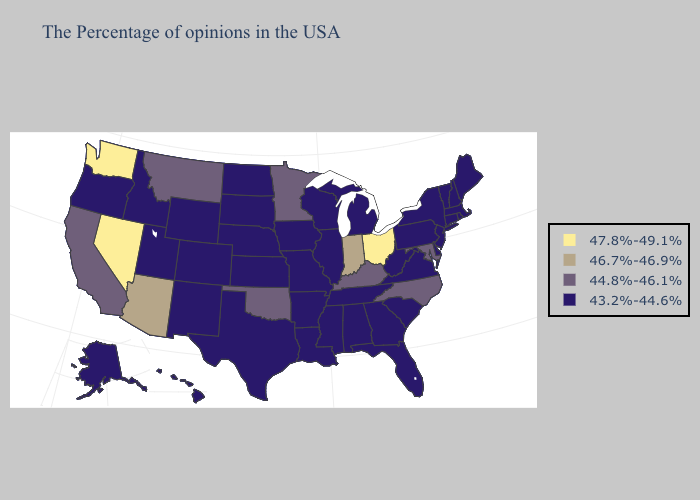Name the states that have a value in the range 44.8%-46.1%?
Answer briefly. Maryland, North Carolina, Kentucky, Minnesota, Oklahoma, Montana, California. What is the lowest value in the Northeast?
Concise answer only. 43.2%-44.6%. Does Ohio have the lowest value in the USA?
Quick response, please. No. What is the value of Alabama?
Short answer required. 43.2%-44.6%. What is the highest value in the West ?
Write a very short answer. 47.8%-49.1%. What is the lowest value in the MidWest?
Concise answer only. 43.2%-44.6%. Which states hav the highest value in the MidWest?
Be succinct. Ohio. Does Ohio have the highest value in the MidWest?
Be succinct. Yes. Name the states that have a value in the range 43.2%-44.6%?
Concise answer only. Maine, Massachusetts, Rhode Island, New Hampshire, Vermont, Connecticut, New York, New Jersey, Delaware, Pennsylvania, Virginia, South Carolina, West Virginia, Florida, Georgia, Michigan, Alabama, Tennessee, Wisconsin, Illinois, Mississippi, Louisiana, Missouri, Arkansas, Iowa, Kansas, Nebraska, Texas, South Dakota, North Dakota, Wyoming, Colorado, New Mexico, Utah, Idaho, Oregon, Alaska, Hawaii. What is the highest value in the USA?
Be succinct. 47.8%-49.1%. What is the value of North Dakota?
Concise answer only. 43.2%-44.6%. What is the value of Mississippi?
Answer briefly. 43.2%-44.6%. Does Missouri have the lowest value in the USA?
Concise answer only. Yes. Name the states that have a value in the range 44.8%-46.1%?
Short answer required. Maryland, North Carolina, Kentucky, Minnesota, Oklahoma, Montana, California. Which states have the highest value in the USA?
Write a very short answer. Ohio, Nevada, Washington. 